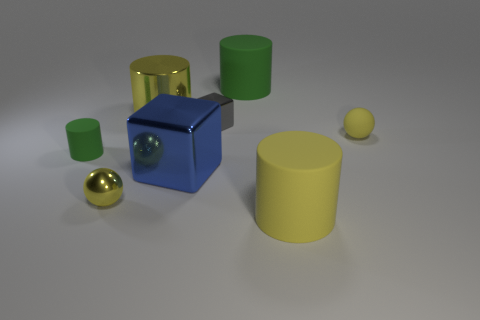What material is the other large cylinder that is the same color as the metal cylinder?
Provide a short and direct response. Rubber. How many large blue cubes have the same material as the tiny gray block?
Your response must be concise. 1. Are there any large green rubber things?
Keep it short and to the point. Yes. There is a green matte object left of the big blue shiny cube; what is its size?
Offer a terse response. Small. How many cylinders have the same color as the big metallic cube?
Give a very brief answer. 0. What number of balls are small gray shiny objects or small rubber things?
Provide a short and direct response. 1. The large object that is both behind the big blue cube and to the left of the gray shiny object has what shape?
Ensure brevity in your answer.  Cylinder. Are there any green matte cylinders that have the same size as the shiny cylinder?
Keep it short and to the point. Yes. What number of things are small yellow balls behind the big blue shiny object or red rubber spheres?
Offer a terse response. 1. Is the blue cube made of the same material as the cylinder that is in front of the blue metallic object?
Give a very brief answer. No. 